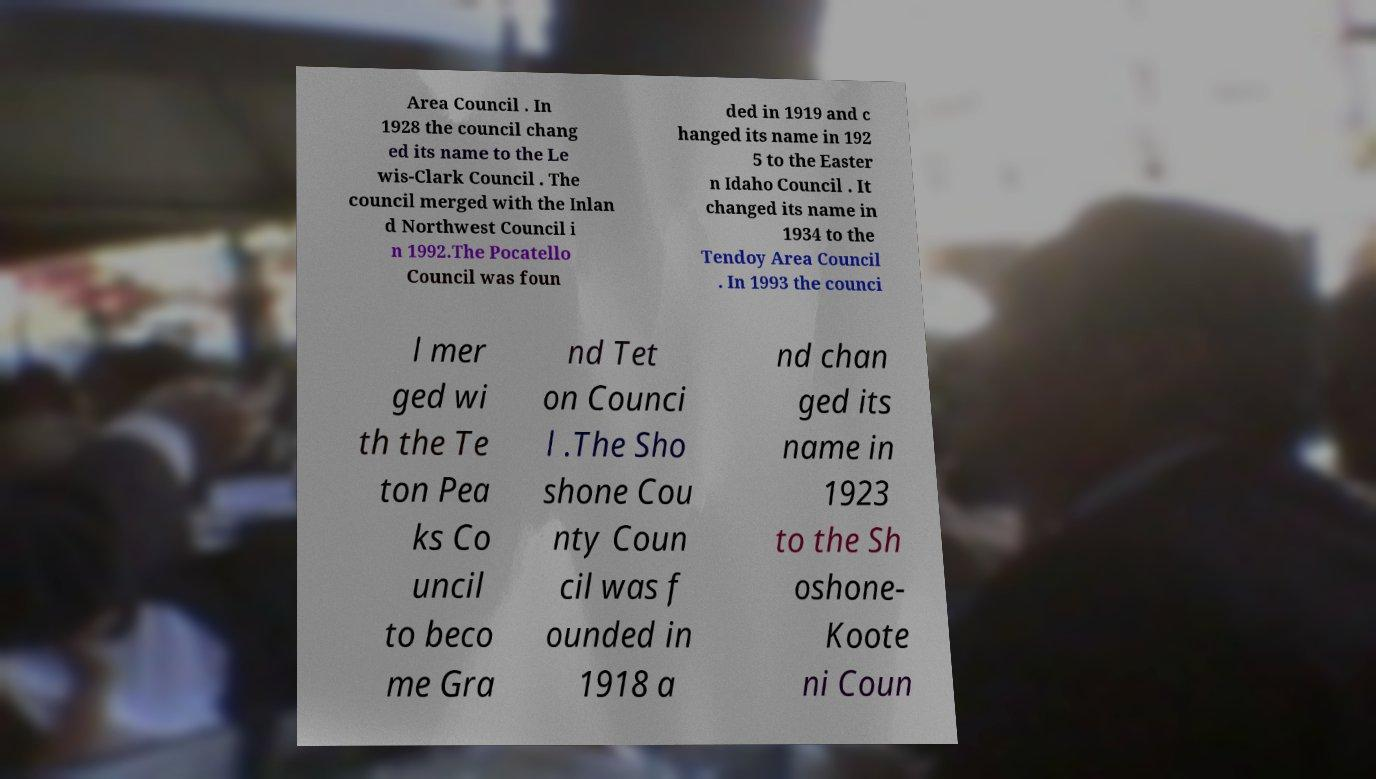Please identify and transcribe the text found in this image. Area Council . In 1928 the council chang ed its name to the Le wis-Clark Council . The council merged with the Inlan d Northwest Council i n 1992.The Pocatello Council was foun ded in 1919 and c hanged its name in 192 5 to the Easter n Idaho Council . It changed its name in 1934 to the Tendoy Area Council . In 1993 the counci l mer ged wi th the Te ton Pea ks Co uncil to beco me Gra nd Tet on Counci l .The Sho shone Cou nty Coun cil was f ounded in 1918 a nd chan ged its name in 1923 to the Sh oshone- Koote ni Coun 